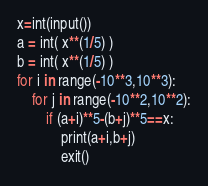Convert code to text. <code><loc_0><loc_0><loc_500><loc_500><_Python_>x=int(input())
a = int( x**(1/5) )
b = int( x**(1/5) )
for i in range(-10**3,10**3):
    for j in range(-10**2,10**2):
        if (a+i)**5-(b+j)**5==x:
            print(a+i,b+j)
            exit()</code> 